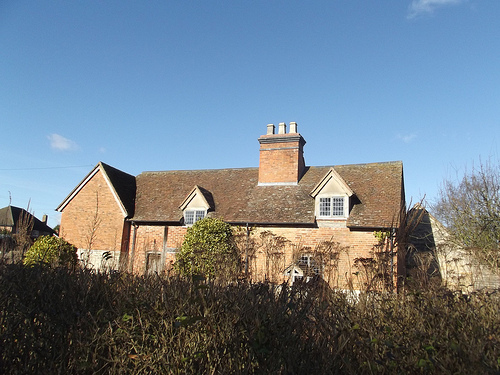<image>
Can you confirm if the tree is on the roof? No. The tree is not positioned on the roof. They may be near each other, but the tree is not supported by or resting on top of the roof. 